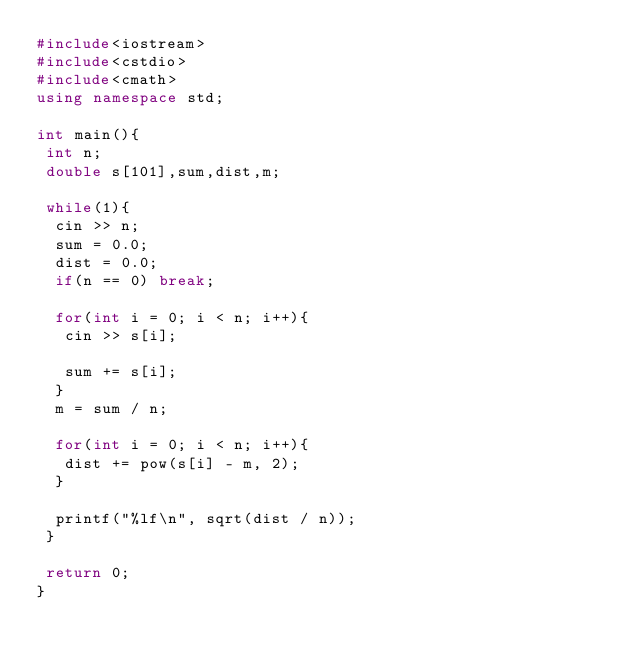Convert code to text. <code><loc_0><loc_0><loc_500><loc_500><_C++_>#include<iostream>
#include<cstdio>
#include<cmath>
using namespace std;

int main(){
 int n;
 double s[101],sum,dist,m;

 while(1){
  cin >> n;
  sum = 0.0;
  dist = 0.0;
  if(n == 0) break;

  for(int i = 0; i < n; i++){
   cin >> s[i];

   sum += s[i];
  }
  m = sum / n; 
 
  for(int i = 0; i < n; i++){
   dist += pow(s[i] - m, 2);
  }

  printf("%lf\n", sqrt(dist / n));
 }

 return 0;
}</code> 